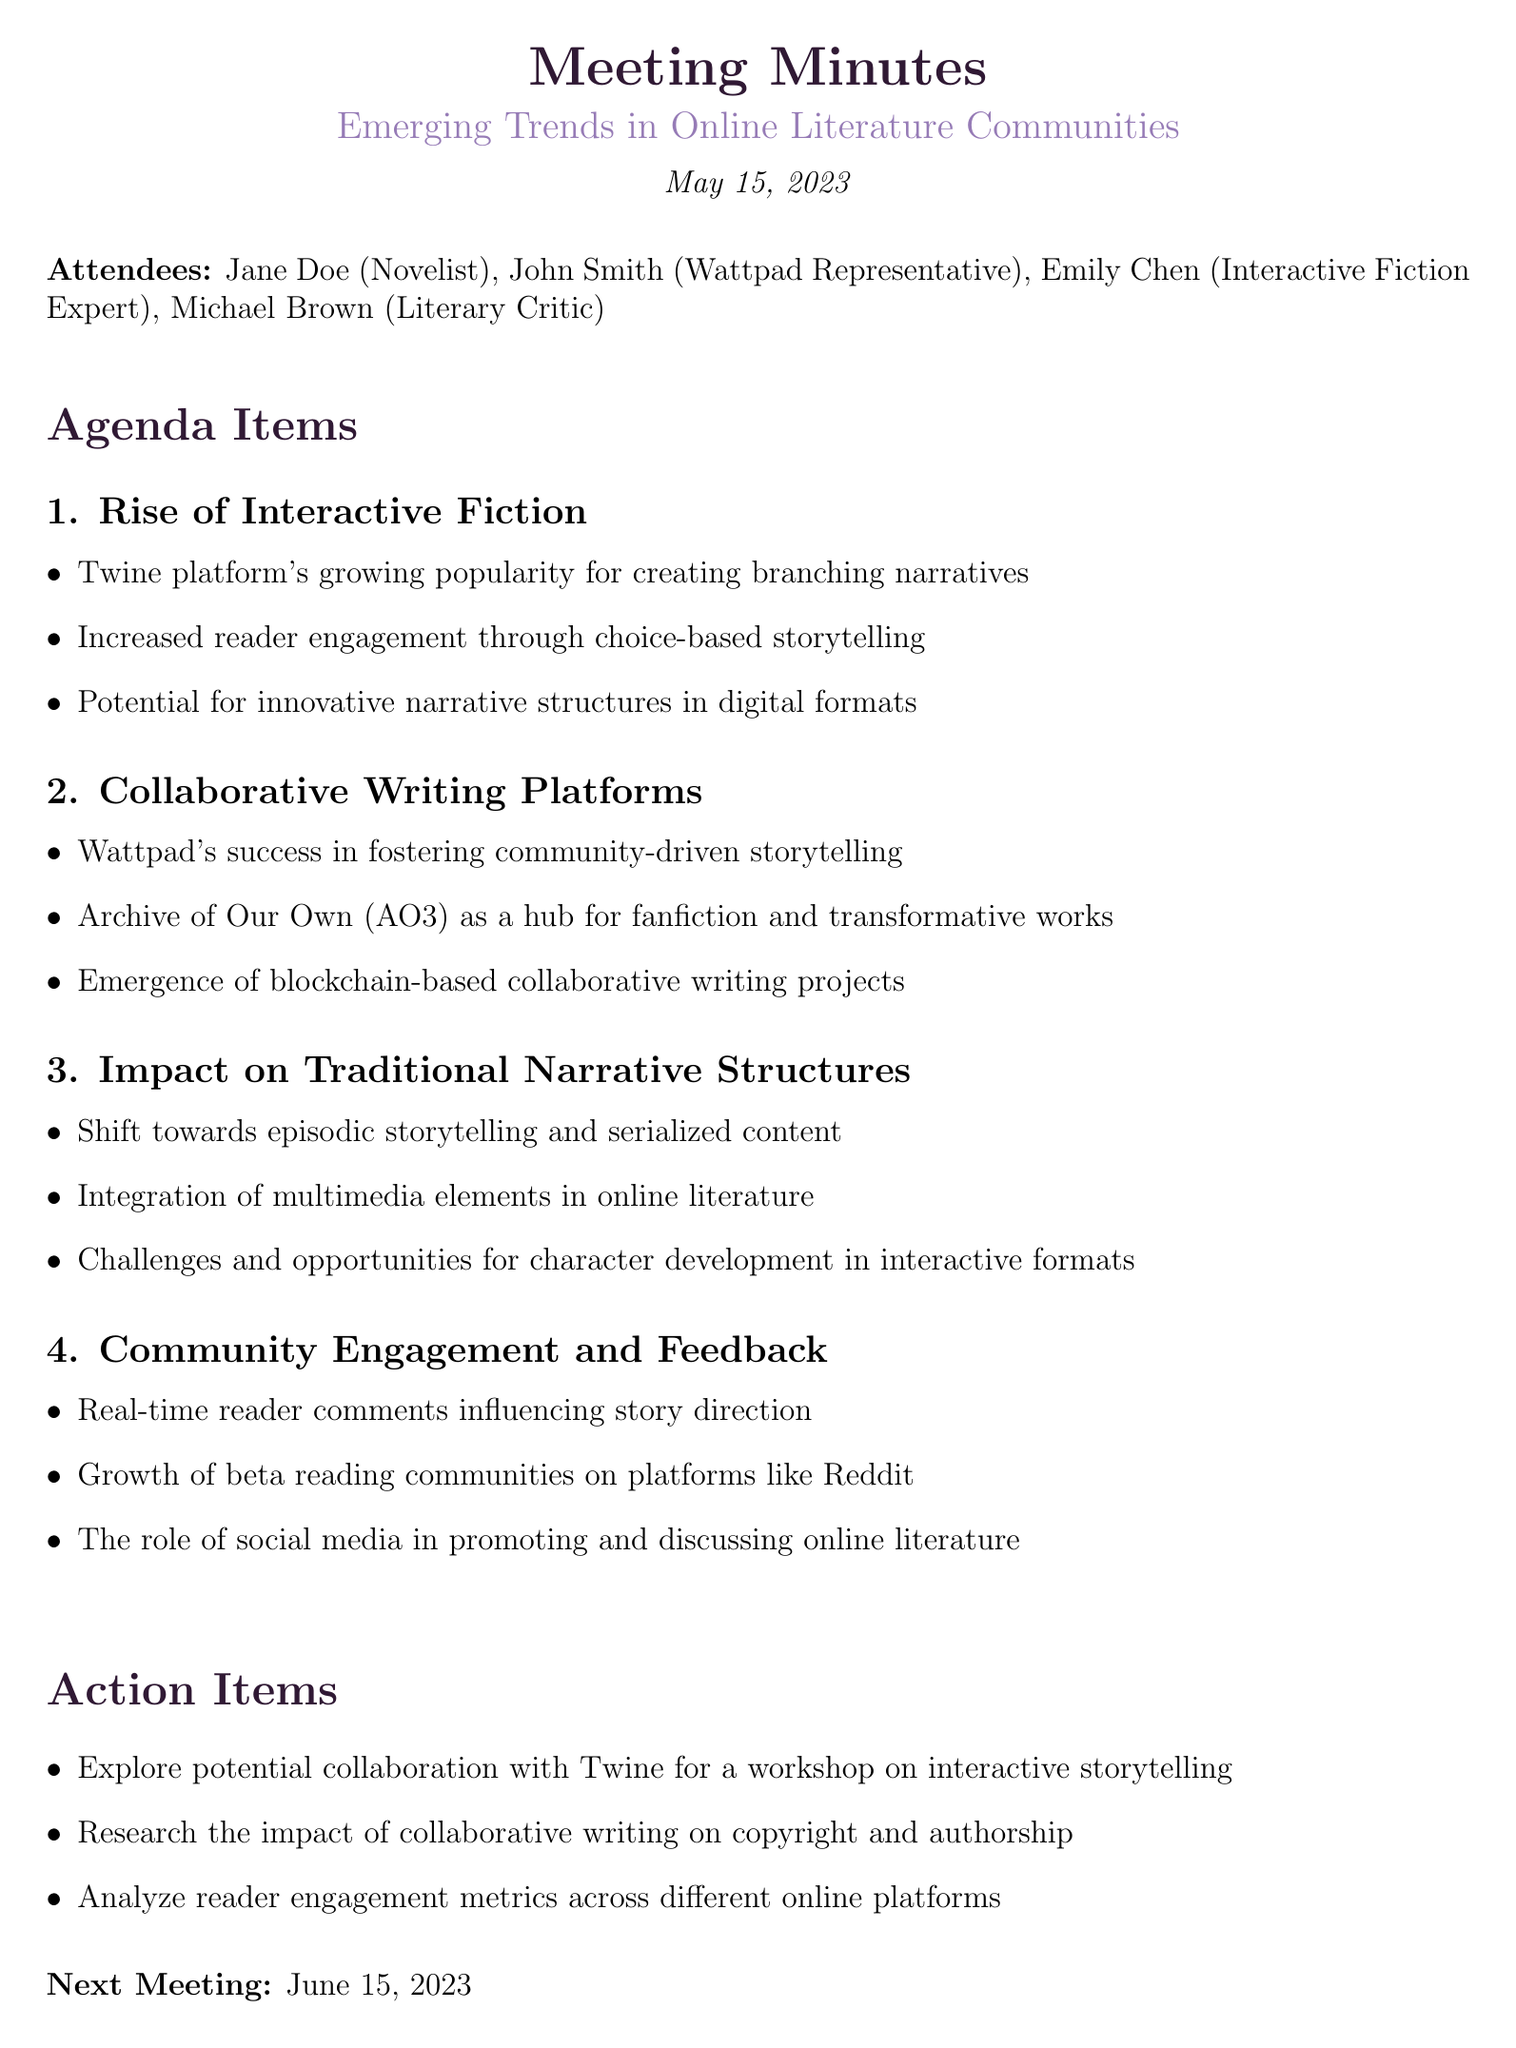what is the date of the meeting? The date of the meeting is listed at the beginning of the document.
Answer: May 15, 2023 who is the interactive fiction expert present at the meeting? The attendees section mentions the roles of each individual present, including their expertise.
Answer: Emily Chen what platform is mentioned as successful in fostering community-driven storytelling? This information is found in the agenda item discussing collaborative writing platforms.
Answer: Wattpad what is one of the action items discussed in the meeting? The action items are outlined at the end of the document, summarizing tasks to be addressed post-meeting.
Answer: Explore potential collaboration with Twine for a workshop on interactive storytelling how does the document categorize the impact on traditional narrative structures? This aspect is discussed in the points listed under the agenda item regarding traditional narrative structures.
Answer: Shift towards episodic storytelling and serialized content what is the next meeting date scheduled? The next meeting date is noted at the end of the document.
Answer: June 15, 2023 which platform is identified as a hub for fanfiction and transformative works? The point in the collaborative writing platforms section specifies this platform.
Answer: Archive of Our Own (AO3) what type of storytelling is emphasized in the rise of interactive fiction? This focus is highlighted in the specific points discussing the rise of interactive fiction.
Answer: Choice-based storytelling 